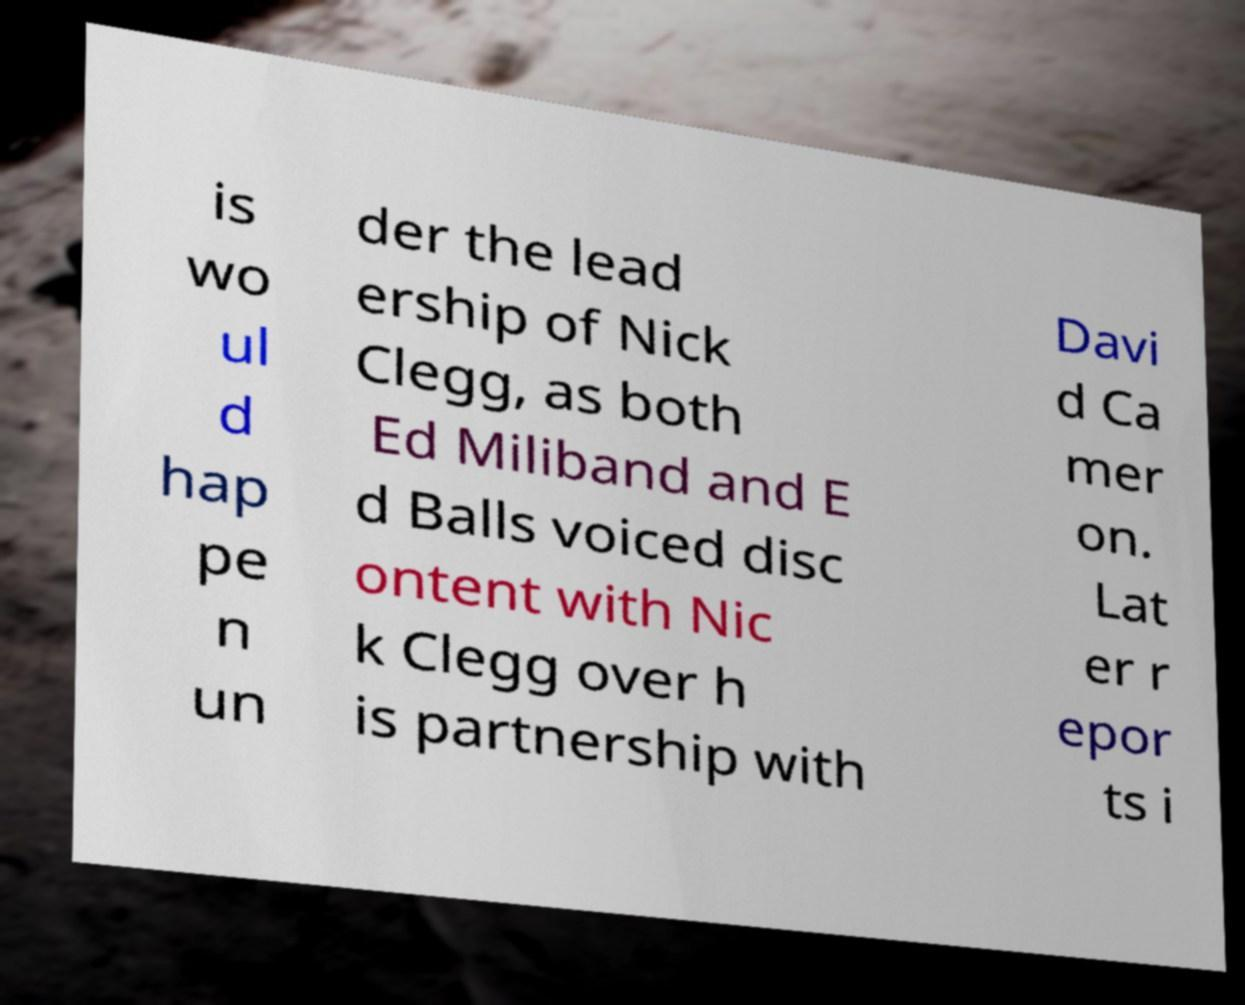Could you extract and type out the text from this image? is wo ul d hap pe n un der the lead ership of Nick Clegg, as both Ed Miliband and E d Balls voiced disc ontent with Nic k Clegg over h is partnership with Davi d Ca mer on. Lat er r epor ts i 